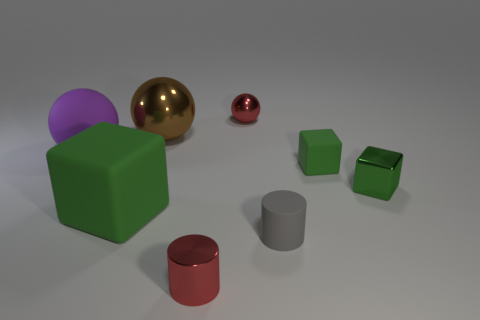There is a small green shiny thing; what shape is it?
Keep it short and to the point. Cube. What number of yellow objects are small metallic cylinders or tiny things?
Your answer should be very brief. 0. What number of other things are made of the same material as the large green object?
Your response must be concise. 3. Do the large object that is on the left side of the large matte block and the large green object have the same shape?
Provide a succinct answer. No. Are there any big red rubber spheres?
Provide a succinct answer. No. Are there any other things that have the same shape as the gray matte object?
Give a very brief answer. Yes. Are there more purple matte spheres in front of the green metal object than large brown objects?
Offer a terse response. No. Are there any objects behind the gray thing?
Give a very brief answer. Yes. Is the size of the gray matte thing the same as the brown object?
Ensure brevity in your answer.  No. What is the size of the brown thing that is the same shape as the purple rubber object?
Offer a very short reply. Large. 